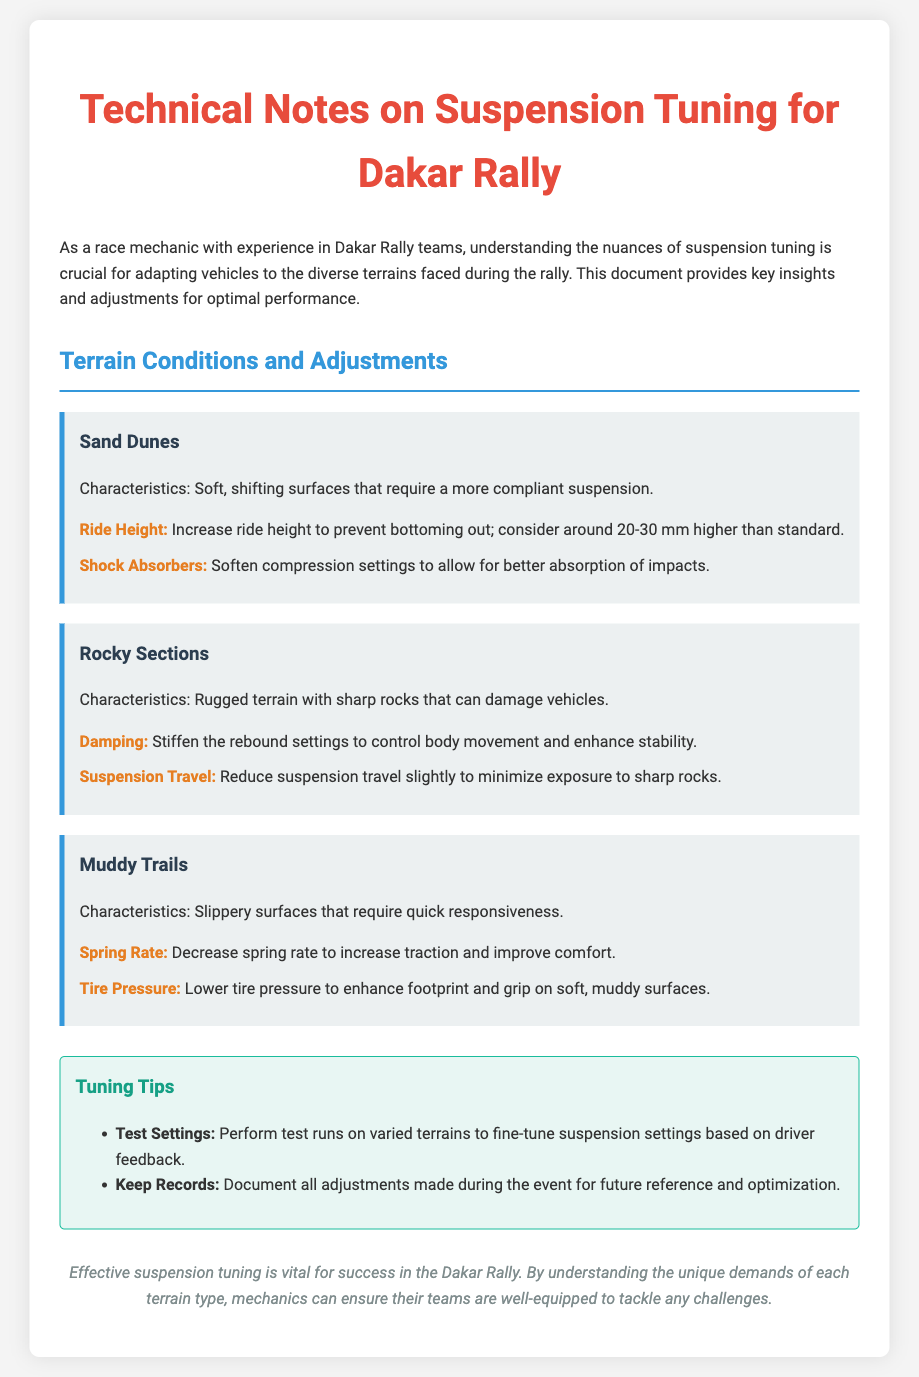What is the title of the document? The title is mentioned at the top of the document in the header section.
Answer: Technical Notes on Suspension Tuning for Dakar Rally What adjustment is recommended for ride height in sand dunes? The document specifies an adjustment to ride height to prevent bottoming out specifically for sand dunes.
Answer: Increase ride height to 20-30 mm higher than standard What should be done to the shock absorbers in sandy terrain? The adjustments needed for shock absorbers can be found under the sand dunes section.
Answer: Soften compression settings What type of terrain requires a stiffer rebound setting? This information is provided in the section about rocky sections where adjusting settings is necessary for stability.
Answer: Rocky Sections What is advised regarding spring rate on muddy trails? The information is provided in the muddy trails section regarding traction and comfort adjustments.
Answer: Decrease spring rate What is a tuning tip from the document? The document includes two tips for tuning; one of them can be highlighted for its importance.
Answer: Perform test runs on varied terrains What is a unique characteristic of muddy trails? Characteristics of muddy trails are specified in the respective section of the document, highlighting its nature.
Answer: Slippery surfaces What is the purpose of adjusting tire pressure in muddy conditions? The reasoning behind adjusting tire pressure is elaborated in the muddy trails section.
Answer: Enhance footprint and grip What is the overall conclusion about suspension tuning? The conclusion sums up the importance of the tuning practices discussed throughout the document.
Answer: Effective suspension tuning is vital for success 